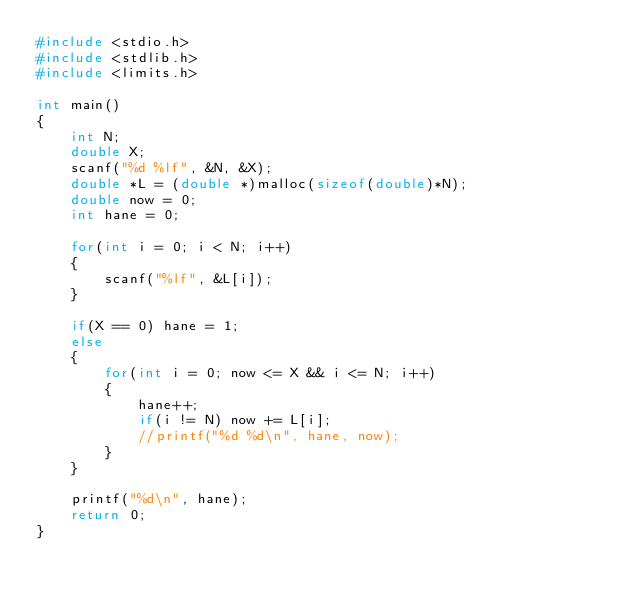Convert code to text. <code><loc_0><loc_0><loc_500><loc_500><_C_>#include <stdio.h>
#include <stdlib.h>
#include <limits.h>

int main()
{
    int N;
    double X;
    scanf("%d %lf", &N, &X);
    double *L = (double *)malloc(sizeof(double)*N);
    double now = 0;
    int hane = 0;

    for(int i = 0; i < N; i++)
    {
        scanf("%lf", &L[i]);
    }

    if(X == 0) hane = 1;
    else
    {
        for(int i = 0; now <= X && i <= N; i++)
        {
            hane++;
            if(i != N) now += L[i];
            //printf("%d %d\n", hane, now);
        }
    }
    
    printf("%d\n", hane);
    return 0;
}</code> 